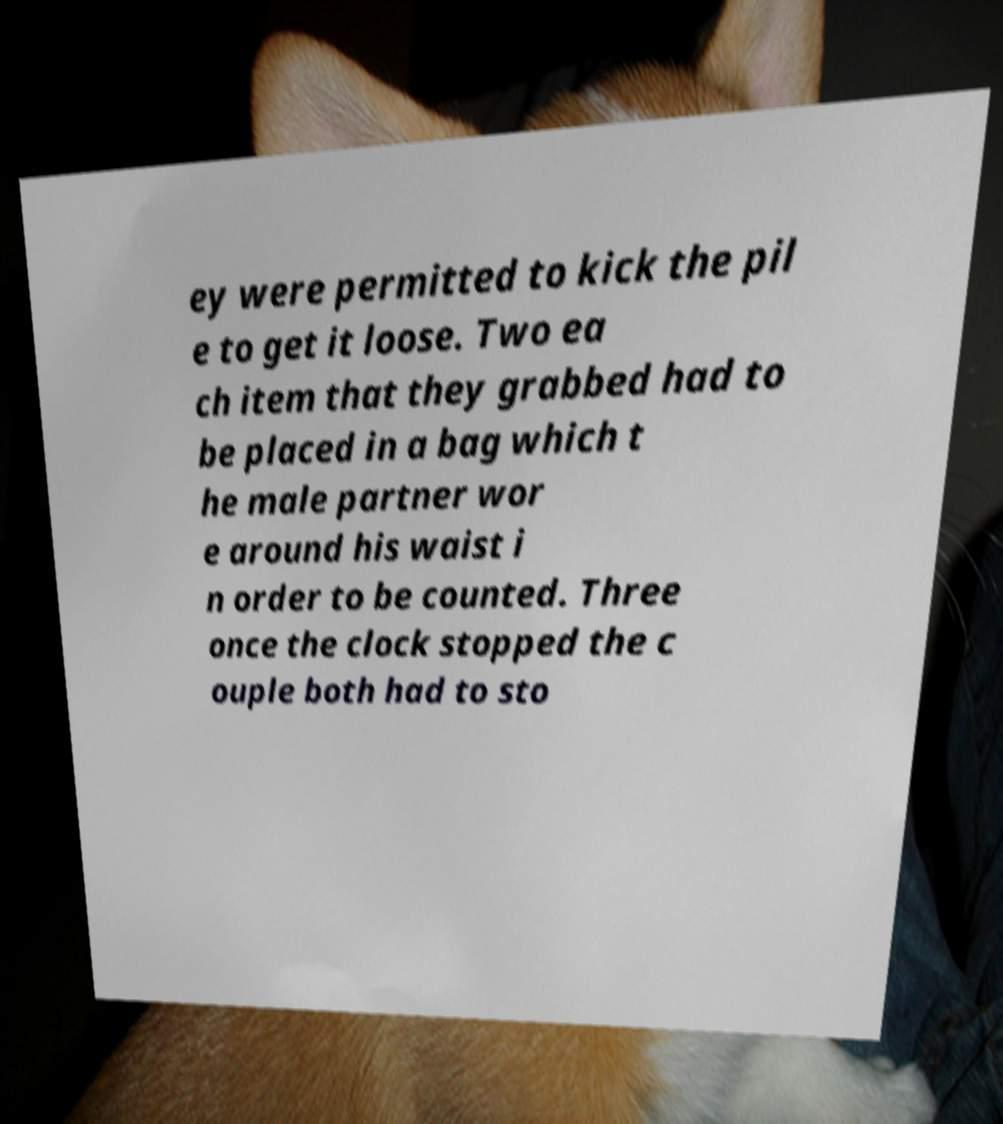Can you accurately transcribe the text from the provided image for me? ey were permitted to kick the pil e to get it loose. Two ea ch item that they grabbed had to be placed in a bag which t he male partner wor e around his waist i n order to be counted. Three once the clock stopped the c ouple both had to sto 